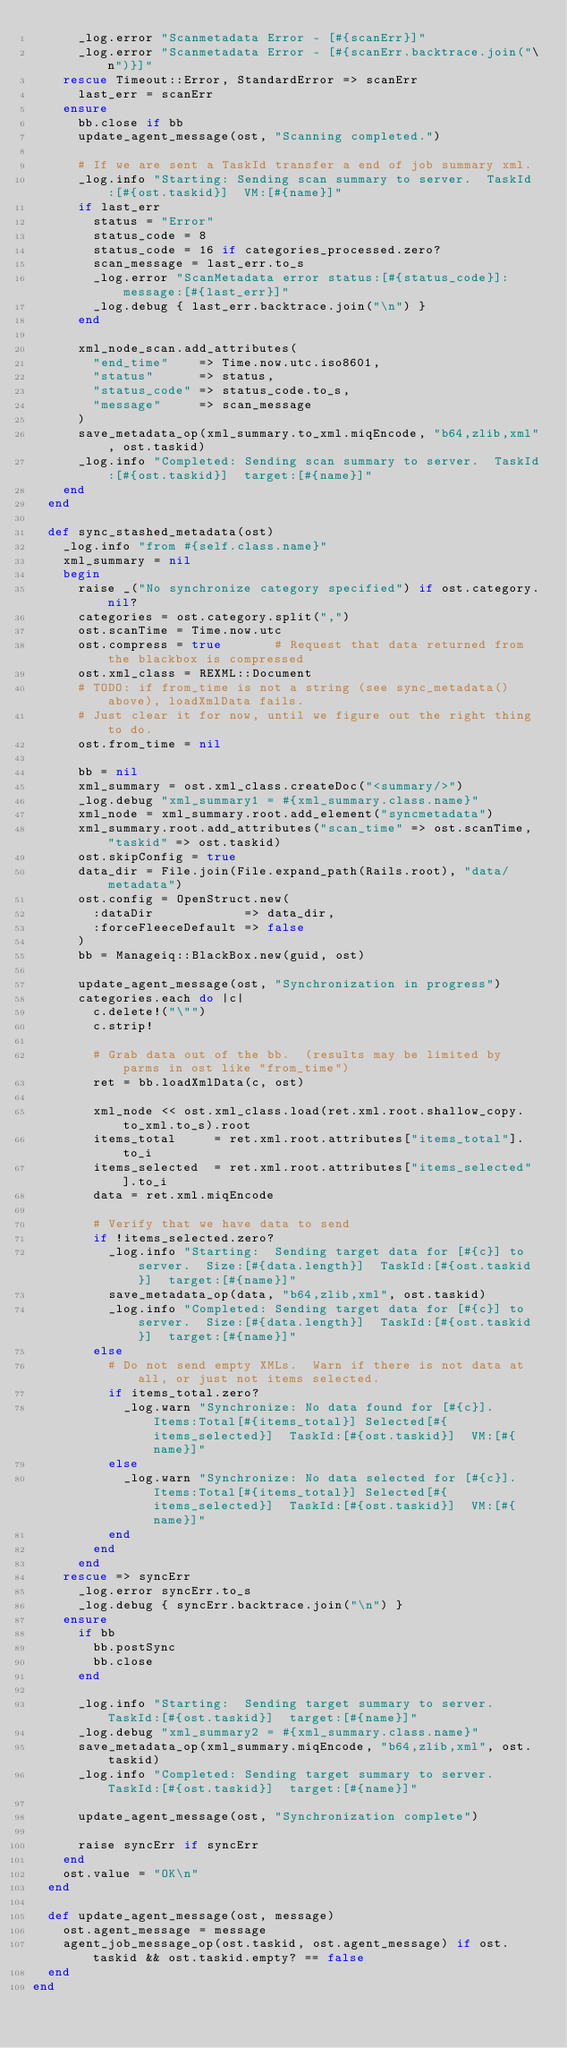<code> <loc_0><loc_0><loc_500><loc_500><_Ruby_>      _log.error "Scanmetadata Error - [#{scanErr}]"
      _log.error "Scanmetadata Error - [#{scanErr.backtrace.join("\n")}]"
    rescue Timeout::Error, StandardError => scanErr
      last_err = scanErr
    ensure
      bb.close if bb
      update_agent_message(ost, "Scanning completed.")

      # If we are sent a TaskId transfer a end of job summary xml.
      _log.info "Starting: Sending scan summary to server.  TaskId:[#{ost.taskid}]  VM:[#{name}]"
      if last_err
        status = "Error"
        status_code = 8
        status_code = 16 if categories_processed.zero?
        scan_message = last_err.to_s
        _log.error "ScanMetadata error status:[#{status_code}]:  message:[#{last_err}]"
        _log.debug { last_err.backtrace.join("\n") }
      end

      xml_node_scan.add_attributes(
        "end_time"    => Time.now.utc.iso8601,
        "status"      => status,
        "status_code" => status_code.to_s,
        "message"     => scan_message
      )
      save_metadata_op(xml_summary.to_xml.miqEncode, "b64,zlib,xml", ost.taskid)
      _log.info "Completed: Sending scan summary to server.  TaskId:[#{ost.taskid}]  target:[#{name}]"
    end
  end

  def sync_stashed_metadata(ost)
    _log.info "from #{self.class.name}"
    xml_summary = nil
    begin
      raise _("No synchronize category specified") if ost.category.nil?
      categories = ost.category.split(",")
      ost.scanTime = Time.now.utc
      ost.compress = true       # Request that data returned from the blackbox is compressed
      ost.xml_class = REXML::Document
      # TODO: if from_time is not a string (see sync_metadata() above), loadXmlData fails.
      # Just clear it for now, until we figure out the right thing to do.
      ost.from_time = nil

      bb = nil
      xml_summary = ost.xml_class.createDoc("<summary/>")
      _log.debug "xml_summary1 = #{xml_summary.class.name}"
      xml_node = xml_summary.root.add_element("syncmetadata")
      xml_summary.root.add_attributes("scan_time" => ost.scanTime, "taskid" => ost.taskid)
      ost.skipConfig = true
      data_dir = File.join(File.expand_path(Rails.root), "data/metadata")
      ost.config = OpenStruct.new(
        :dataDir            => data_dir,
        :forceFleeceDefault => false
      )
      bb = Manageiq::BlackBox.new(guid, ost)

      update_agent_message(ost, "Synchronization in progress")
      categories.each do |c|
        c.delete!("\"")
        c.strip!

        # Grab data out of the bb.  (results may be limited by parms in ost like "from_time")
        ret = bb.loadXmlData(c, ost)

        xml_node << ost.xml_class.load(ret.xml.root.shallow_copy.to_xml.to_s).root
        items_total     = ret.xml.root.attributes["items_total"].to_i
        items_selected  = ret.xml.root.attributes["items_selected"].to_i
        data = ret.xml.miqEncode

        # Verify that we have data to send
        if !items_selected.zero?
          _log.info "Starting:  Sending target data for [#{c}] to server.  Size:[#{data.length}]  TaskId:[#{ost.taskid}]  target:[#{name}]"
          save_metadata_op(data, "b64,zlib,xml", ost.taskid)
          _log.info "Completed: Sending target data for [#{c}] to server.  Size:[#{data.length}]  TaskId:[#{ost.taskid}]  target:[#{name}]"
        else
          # Do not send empty XMLs.  Warn if there is not data at all, or just not items selected.
          if items_total.zero?
            _log.warn "Synchronize: No data found for [#{c}].  Items:Total[#{items_total}] Selected[#{items_selected}]  TaskId:[#{ost.taskid}]  VM:[#{name}]"
          else
            _log.warn "Synchronize: No data selected for [#{c}].  Items:Total[#{items_total}] Selected[#{items_selected}]  TaskId:[#{ost.taskid}]  VM:[#{name}]"
          end
        end
      end
    rescue => syncErr
      _log.error syncErr.to_s
      _log.debug { syncErr.backtrace.join("\n") }
    ensure
      if bb
        bb.postSync
        bb.close
      end

      _log.info "Starting:  Sending target summary to server.  TaskId:[#{ost.taskid}]  target:[#{name}]"
      _log.debug "xml_summary2 = #{xml_summary.class.name}"
      save_metadata_op(xml_summary.miqEncode, "b64,zlib,xml", ost.taskid)
      _log.info "Completed: Sending target summary to server.  TaskId:[#{ost.taskid}]  target:[#{name}]"

      update_agent_message(ost, "Synchronization complete")

      raise syncErr if syncErr
    end
    ost.value = "OK\n"
  end

  def update_agent_message(ost, message)
    ost.agent_message = message
    agent_job_message_op(ost.taskid, ost.agent_message) if ost.taskid && ost.taskid.empty? == false
  end
end
</code> 